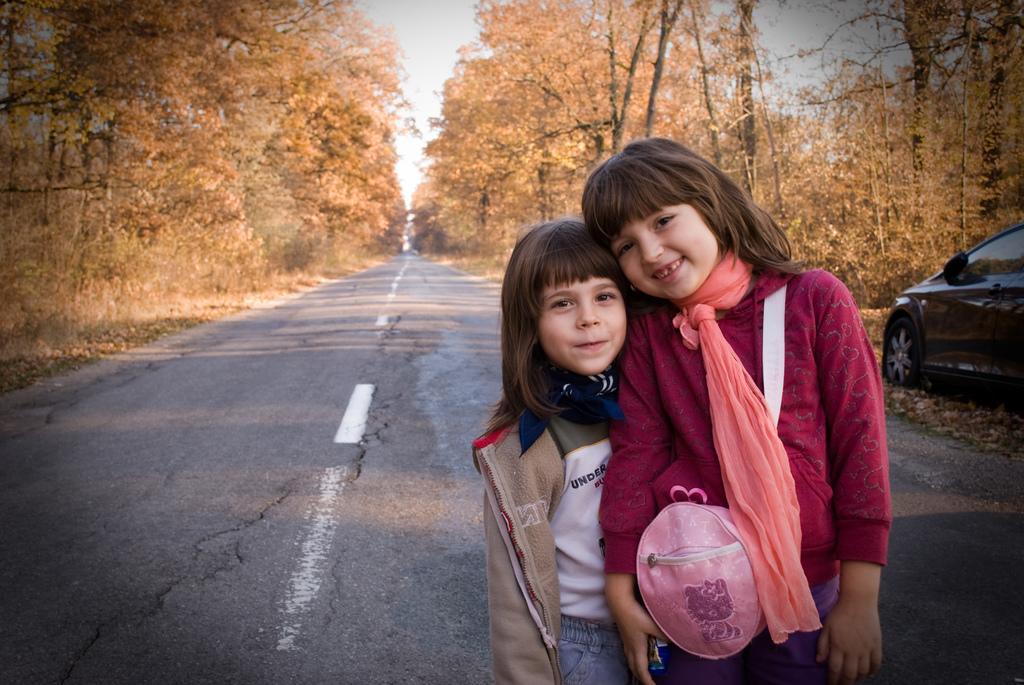Please provide a concise description of this image. In this image there are two kids standing one beside the other on the road. The girl on the right side is wearing the bag. On the right side there is a car on the ground. There are trees on either side of the road. At the top there is the sky. 